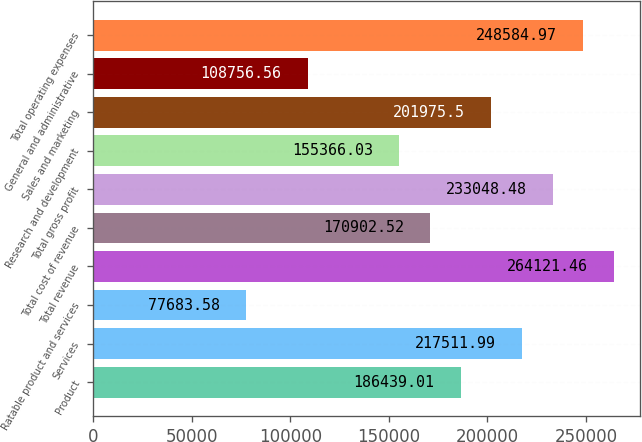Convert chart. <chart><loc_0><loc_0><loc_500><loc_500><bar_chart><fcel>Product<fcel>Services<fcel>Ratable product and services<fcel>Total revenue<fcel>Total cost of revenue<fcel>Total gross profit<fcel>Research and development<fcel>Sales and marketing<fcel>General and administrative<fcel>Total operating expenses<nl><fcel>186439<fcel>217512<fcel>77683.6<fcel>264121<fcel>170903<fcel>233048<fcel>155366<fcel>201976<fcel>108757<fcel>248585<nl></chart> 